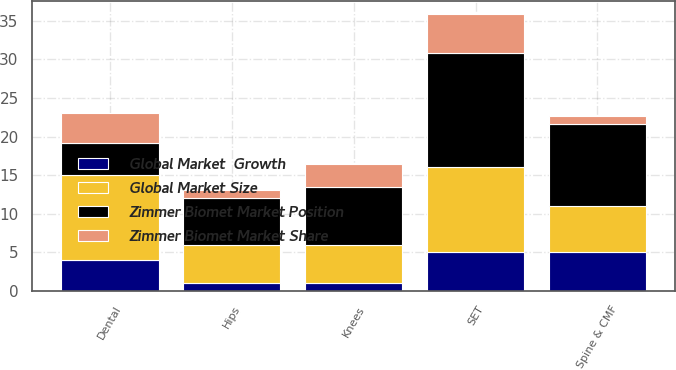<chart> <loc_0><loc_0><loc_500><loc_500><stacked_bar_chart><ecel><fcel>Knees<fcel>Hips<fcel>SET<fcel>Dental<fcel>Spine & CMF<nl><fcel>Zimmer Biomet Market Position<fcel>7.5<fcel>6.1<fcel>14.8<fcel>4.1<fcel>10.6<nl><fcel>Zimmer Biomet Market Share<fcel>3<fcel>1<fcel>5<fcel>4<fcel>1<nl><fcel>Global Market Size<fcel>5<fcel>5<fcel>11<fcel>11<fcel>6<nl><fcel>Global Market  Growth<fcel>1<fcel>1<fcel>5<fcel>4<fcel>5<nl></chart> 